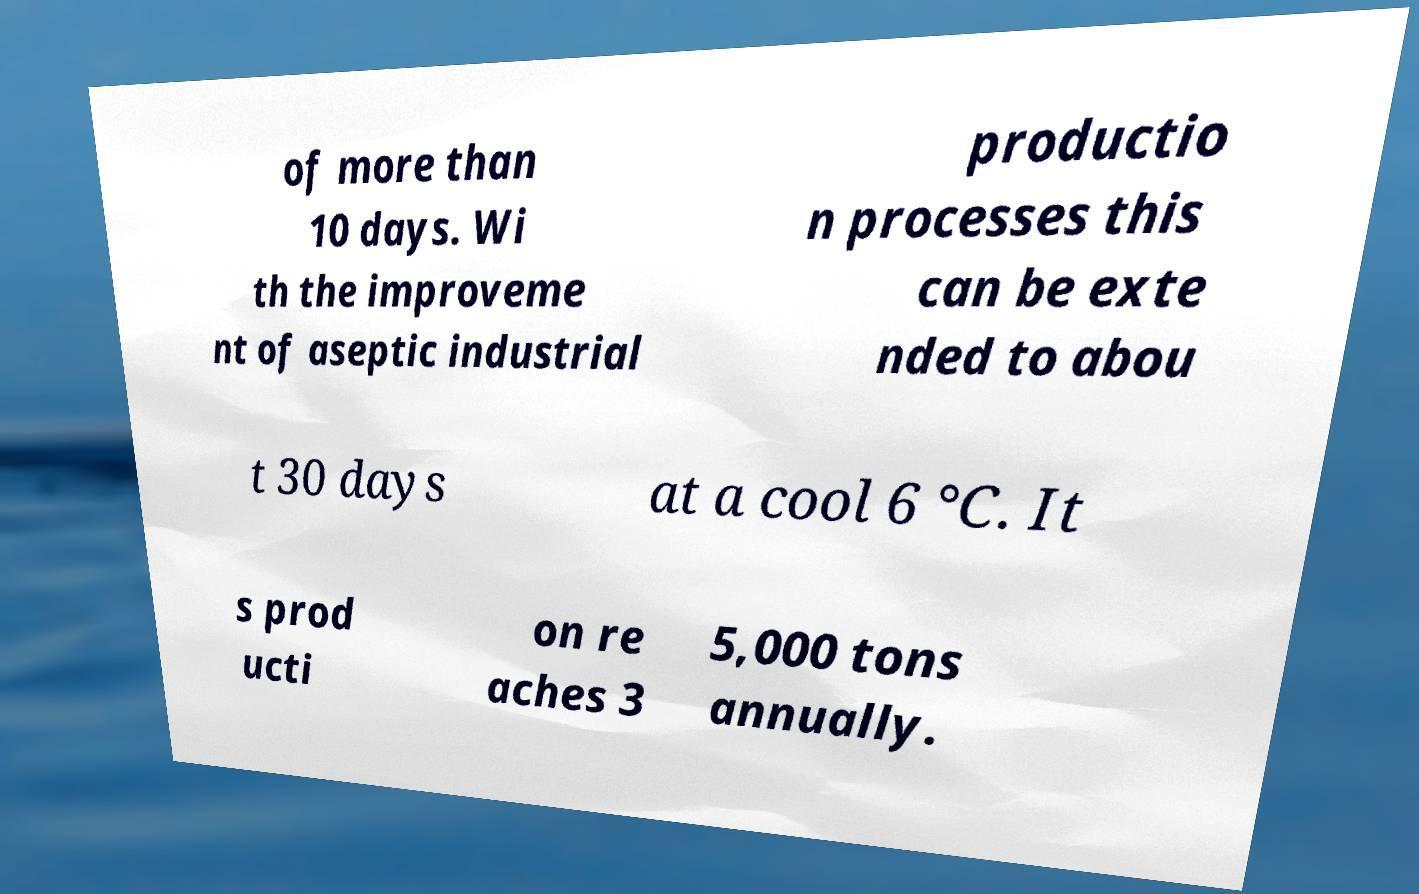What messages or text are displayed in this image? I need them in a readable, typed format. of more than 10 days. Wi th the improveme nt of aseptic industrial productio n processes this can be exte nded to abou t 30 days at a cool 6 °C. It s prod ucti on re aches 3 5,000 tons annually. 